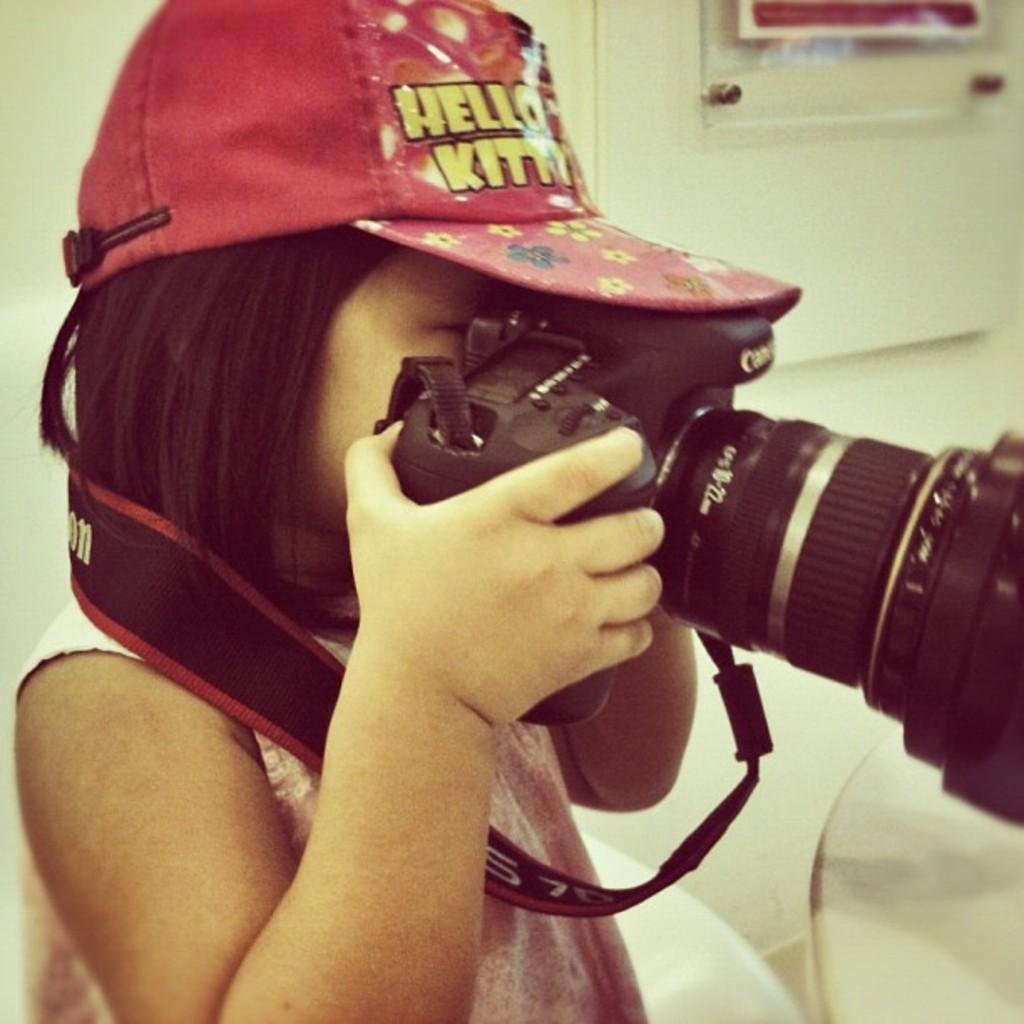Who is the main subject in the image? There is a girl in the image. What is the girl holding in the image? The girl is holding a camera. What is the girl wearing on her head? The girl is wearing a cap. What can be seen in the background of the image? There is a board, a wall, and other objects in the background of the image. What type of car is parked on the side of the image? There is no car present in the image. What shape is the square object in the background of the image? There is no square object present in the image. 